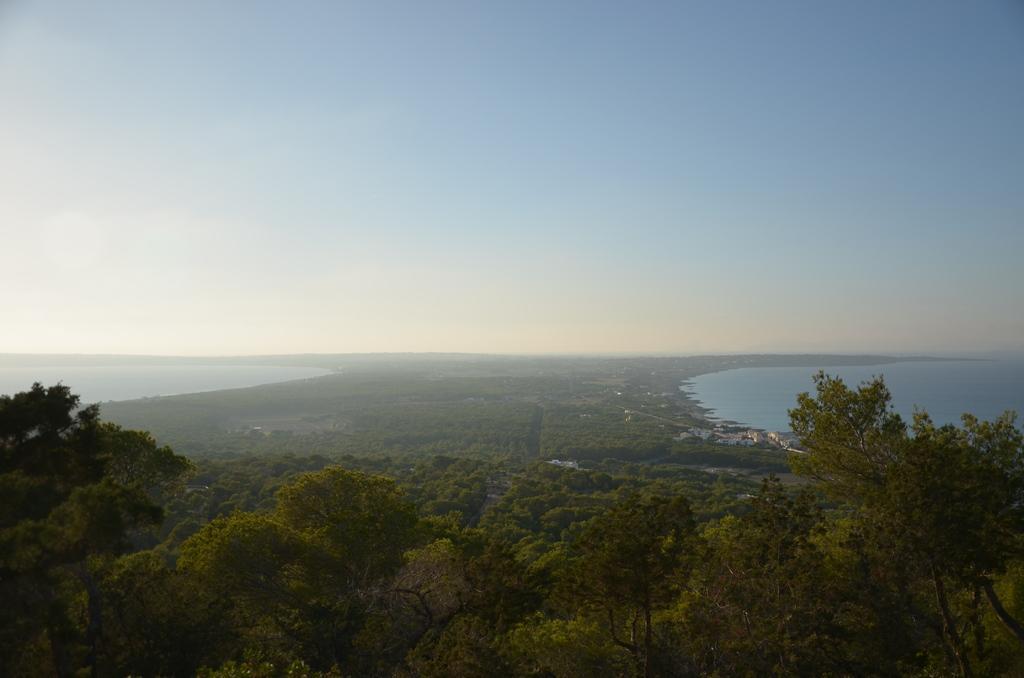Can you describe this image briefly? In this picture we can see few trees and water. 